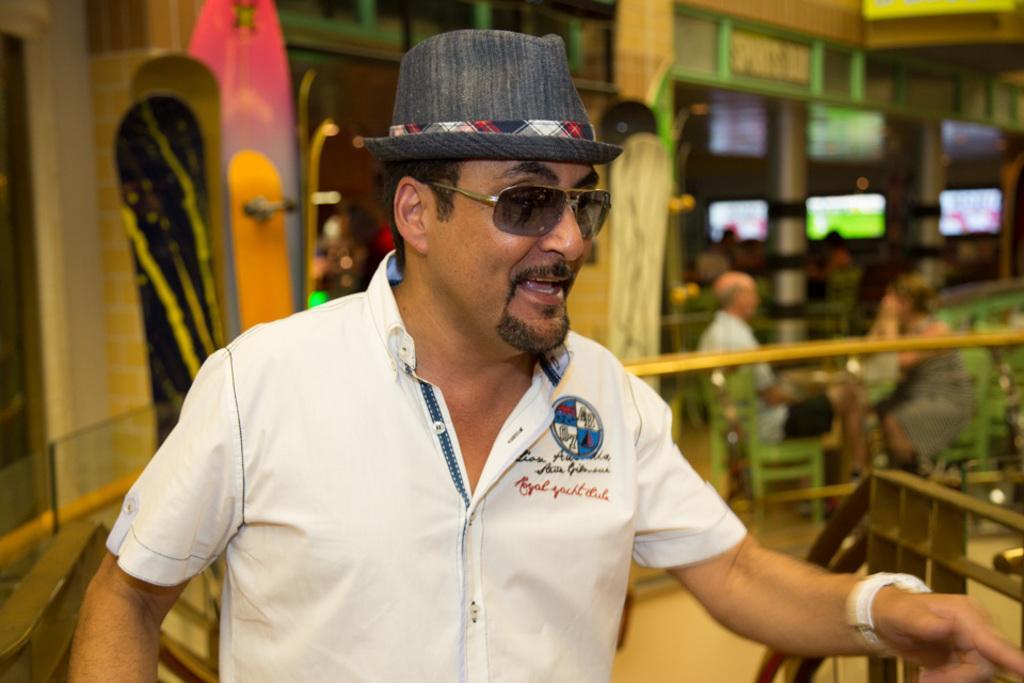Describe this image in one or two sentences. In this image, we can see a person wearing clothes and hat. In the background, image is blurred. 